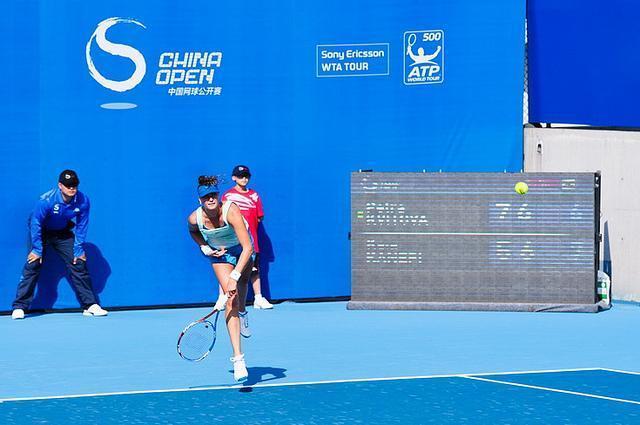How many people are there?
Give a very brief answer. 3. How many zebras do you see?
Give a very brief answer. 0. 